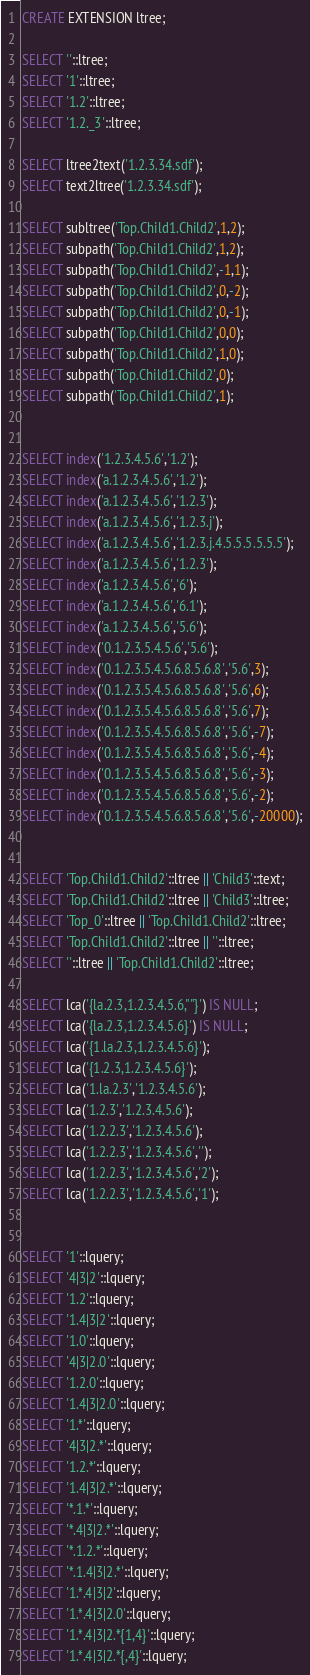Convert code to text. <code><loc_0><loc_0><loc_500><loc_500><_SQL_>CREATE EXTENSION ltree;

SELECT ''::ltree;
SELECT '1'::ltree;
SELECT '1.2'::ltree;
SELECT '1.2._3'::ltree;

SELECT ltree2text('1.2.3.34.sdf');
SELECT text2ltree('1.2.3.34.sdf');

SELECT subltree('Top.Child1.Child2',1,2);
SELECT subpath('Top.Child1.Child2',1,2);
SELECT subpath('Top.Child1.Child2',-1,1);
SELECT subpath('Top.Child1.Child2',0,-2);
SELECT subpath('Top.Child1.Child2',0,-1);
SELECT subpath('Top.Child1.Child2',0,0);
SELECT subpath('Top.Child1.Child2',1,0);
SELECT subpath('Top.Child1.Child2',0);
SELECT subpath('Top.Child1.Child2',1);


SELECT index('1.2.3.4.5.6','1.2');
SELECT index('a.1.2.3.4.5.6','1.2');
SELECT index('a.1.2.3.4.5.6','1.2.3');
SELECT index('a.1.2.3.4.5.6','1.2.3.j');
SELECT index('a.1.2.3.4.5.6','1.2.3.j.4.5.5.5.5.5.5');
SELECT index('a.1.2.3.4.5.6','1.2.3');
SELECT index('a.1.2.3.4.5.6','6');
SELECT index('a.1.2.3.4.5.6','6.1');
SELECT index('a.1.2.3.4.5.6','5.6');
SELECT index('0.1.2.3.5.4.5.6','5.6');
SELECT index('0.1.2.3.5.4.5.6.8.5.6.8','5.6',3);
SELECT index('0.1.2.3.5.4.5.6.8.5.6.8','5.6',6);
SELECT index('0.1.2.3.5.4.5.6.8.5.6.8','5.6',7);
SELECT index('0.1.2.3.5.4.5.6.8.5.6.8','5.6',-7);
SELECT index('0.1.2.3.5.4.5.6.8.5.6.8','5.6',-4);
SELECT index('0.1.2.3.5.4.5.6.8.5.6.8','5.6',-3);
SELECT index('0.1.2.3.5.4.5.6.8.5.6.8','5.6',-2);
SELECT index('0.1.2.3.5.4.5.6.8.5.6.8','5.6',-20000);


SELECT 'Top.Child1.Child2'::ltree || 'Child3'::text;
SELECT 'Top.Child1.Child2'::ltree || 'Child3'::ltree;
SELECT 'Top_0'::ltree || 'Top.Child1.Child2'::ltree;
SELECT 'Top.Child1.Child2'::ltree || ''::ltree;
SELECT ''::ltree || 'Top.Child1.Child2'::ltree;

SELECT lca('{la.2.3,1.2.3.4.5.6,""}') IS NULL;
SELECT lca('{la.2.3,1.2.3.4.5.6}') IS NULL;
SELECT lca('{1.la.2.3,1.2.3.4.5.6}');
SELECT lca('{1.2.3,1.2.3.4.5.6}');
SELECT lca('1.la.2.3','1.2.3.4.5.6');
SELECT lca('1.2.3','1.2.3.4.5.6');
SELECT lca('1.2.2.3','1.2.3.4.5.6');
SELECT lca('1.2.2.3','1.2.3.4.5.6','');
SELECT lca('1.2.2.3','1.2.3.4.5.6','2');
SELECT lca('1.2.2.3','1.2.3.4.5.6','1');


SELECT '1'::lquery;
SELECT '4|3|2'::lquery;
SELECT '1.2'::lquery;
SELECT '1.4|3|2'::lquery;
SELECT '1.0'::lquery;
SELECT '4|3|2.0'::lquery;
SELECT '1.2.0'::lquery;
SELECT '1.4|3|2.0'::lquery;
SELECT '1.*'::lquery;
SELECT '4|3|2.*'::lquery;
SELECT '1.2.*'::lquery;
SELECT '1.4|3|2.*'::lquery;
SELECT '*.1.*'::lquery;
SELECT '*.4|3|2.*'::lquery;
SELECT '*.1.2.*'::lquery;
SELECT '*.1.4|3|2.*'::lquery;
SELECT '1.*.4|3|2'::lquery;
SELECT '1.*.4|3|2.0'::lquery;
SELECT '1.*.4|3|2.*{1,4}'::lquery;
SELECT '1.*.4|3|2.*{,4}'::lquery;</code> 